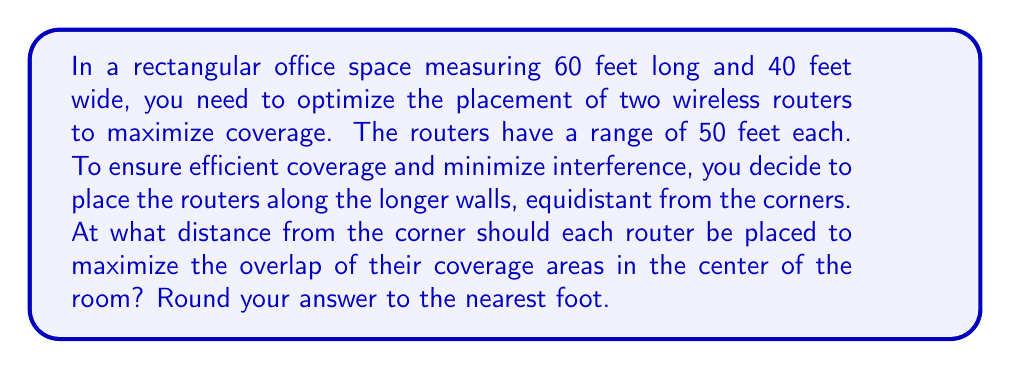Help me with this question. To solve this problem, we'll follow these steps:

1) First, let's visualize the problem:

[asy]
unitsize(2.5pt);
draw((0,0)--(60,0)--(60,40)--(0,40)--cycle);
dot((0,0)); dot((60,0)); dot((60,40)); dot((0,40));
label("60 ft", (30,0), S);
label("40 ft", (0,20), W);
label("x", (0,10), W);
label("x", (60,30), E);
dot((0,10)); dot((60,30));
draw(Circle((0,10),50));
draw(Circle((60,30),50));
[/asy]

2) Let x be the distance from the corner to each router.

3) The centers of the two circles (router coverage areas) are at (0, x) and (60, 40-x).

4) The point where these circles intersect in the center of the room will have coordinates (30, 20).

5) We can use the distance formula to set up an equation. The distance from each router to the center point should equal the router range:

   $$ \sqrt{(30-0)^2 + (20-x)^2} = 50 $$
   $$ \sqrt{(30-60)^2 + (20-(40-x))^2} = 50 $$

6) These equations are identical, so we only need to solve one:

   $$ \sqrt{900 + (20-x)^2} = 50 $$

7) Square both sides:

   $$ 900 + (20-x)^2 = 2500 $$

8) Simplify:

   $$ (20-x)^2 = 1600 $$

9) Take the square root of both sides:

   $$ 20-x = \pm 40 $$

10) Solve for x:

    $$ x = 20 \pm 40 $$

11) Since x represents a distance, it must be positive, so we take the positive solution:

    $$ x = 20 + 40 = 60 $$

12) However, this is greater than the width of the room, so we must use the other solution:

    $$ x = 20 - 40 = -20 $$

13) The absolute value of this gives us the correct distance from the corner:

    $$ |x| = 20 \text{ feet} $$

Therefore, each router should be placed 20 feet from the corner along the longer wall.
Answer: 20 feet 